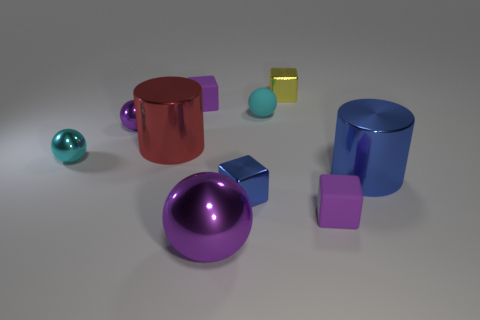Subtract 1 blocks. How many blocks are left? 3 Subtract all spheres. How many objects are left? 6 Subtract all matte spheres. Subtract all blue cylinders. How many objects are left? 8 Add 1 small yellow blocks. How many small yellow blocks are left? 2 Add 5 small blue objects. How many small blue objects exist? 6 Subtract 0 cyan cylinders. How many objects are left? 10 